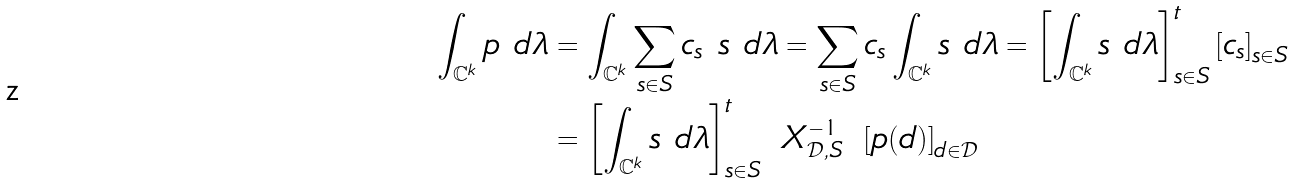Convert formula to latex. <formula><loc_0><loc_0><loc_500><loc_500>\int _ { \mathbb { C } ^ { k } } p \ d \lambda & = \int _ { \mathbb { C } ^ { k } } \sum _ { s \in S } c _ { s } \ s \ d \lambda = \sum _ { s \in S } c _ { s } \int _ { \mathbb { C } ^ { k } } s \ d \lambda = \left [ \int _ { \mathbb { C } ^ { k } } s \ d \lambda \right ] _ { s \in S } ^ { t } \left [ c _ { s } \right ] _ { s \in S } \\ & = \left [ \int _ { \mathbb { C } ^ { k } } s \ d \lambda \right ] _ { s \in S } ^ { t } \ X _ { \mathcal { D } , S } ^ { - 1 } \ \left [ p ( d ) \right ] _ { d \in \mathcal { D } }</formula> 